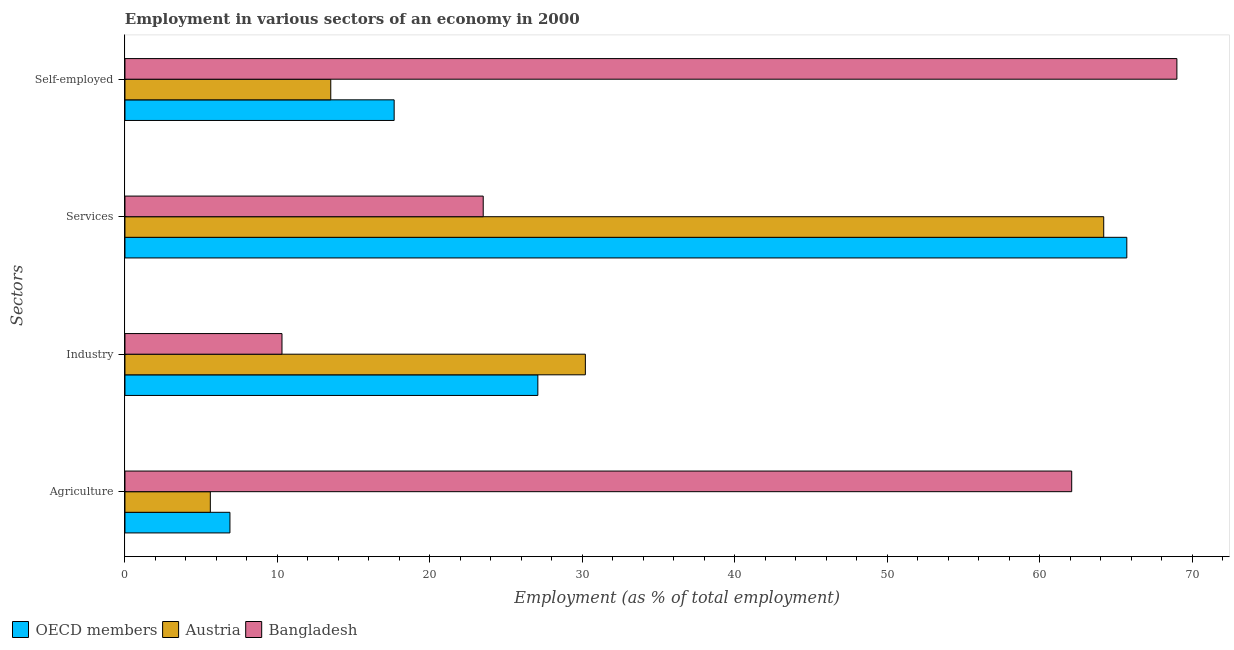How many groups of bars are there?
Offer a very short reply. 4. Are the number of bars per tick equal to the number of legend labels?
Provide a succinct answer. Yes. Are the number of bars on each tick of the Y-axis equal?
Provide a succinct answer. Yes. How many bars are there on the 1st tick from the bottom?
Offer a terse response. 3. What is the label of the 2nd group of bars from the top?
Keep it short and to the point. Services. What is the percentage of workers in industry in Austria?
Your response must be concise. 30.2. Across all countries, what is the maximum percentage of workers in agriculture?
Ensure brevity in your answer.  62.1. In which country was the percentage of self employed workers maximum?
Your answer should be very brief. Bangladesh. In which country was the percentage of workers in services minimum?
Keep it short and to the point. Bangladesh. What is the total percentage of workers in agriculture in the graph?
Make the answer very short. 74.59. What is the difference between the percentage of workers in industry in OECD members and that in Austria?
Keep it short and to the point. -3.12. What is the difference between the percentage of self employed workers in OECD members and the percentage of workers in services in Bangladesh?
Your response must be concise. -5.84. What is the average percentage of workers in agriculture per country?
Provide a succinct answer. 24.86. What is the difference between the percentage of workers in agriculture and percentage of self employed workers in Bangladesh?
Your answer should be compact. -6.9. What is the ratio of the percentage of workers in services in Bangladesh to that in OECD members?
Make the answer very short. 0.36. Is the percentage of self employed workers in Bangladesh less than that in Austria?
Give a very brief answer. No. What is the difference between the highest and the second highest percentage of workers in services?
Ensure brevity in your answer.  1.52. What is the difference between the highest and the lowest percentage of workers in services?
Your answer should be compact. 42.22. In how many countries, is the percentage of workers in agriculture greater than the average percentage of workers in agriculture taken over all countries?
Your answer should be compact. 1. Is it the case that in every country, the sum of the percentage of workers in services and percentage of self employed workers is greater than the sum of percentage of workers in agriculture and percentage of workers in industry?
Provide a succinct answer. No. Is it the case that in every country, the sum of the percentage of workers in agriculture and percentage of workers in industry is greater than the percentage of workers in services?
Provide a short and direct response. No. Are all the bars in the graph horizontal?
Offer a very short reply. Yes. How many countries are there in the graph?
Ensure brevity in your answer.  3. Does the graph contain any zero values?
Your answer should be compact. No. How are the legend labels stacked?
Offer a terse response. Horizontal. What is the title of the graph?
Keep it short and to the point. Employment in various sectors of an economy in 2000. Does "East Asia (all income levels)" appear as one of the legend labels in the graph?
Your answer should be very brief. No. What is the label or title of the X-axis?
Keep it short and to the point. Employment (as % of total employment). What is the label or title of the Y-axis?
Offer a terse response. Sectors. What is the Employment (as % of total employment) of OECD members in Agriculture?
Give a very brief answer. 6.89. What is the Employment (as % of total employment) of Austria in Agriculture?
Keep it short and to the point. 5.6. What is the Employment (as % of total employment) of Bangladesh in Agriculture?
Give a very brief answer. 62.1. What is the Employment (as % of total employment) of OECD members in Industry?
Give a very brief answer. 27.08. What is the Employment (as % of total employment) of Austria in Industry?
Keep it short and to the point. 30.2. What is the Employment (as % of total employment) of Bangladesh in Industry?
Ensure brevity in your answer.  10.3. What is the Employment (as % of total employment) of OECD members in Services?
Keep it short and to the point. 65.72. What is the Employment (as % of total employment) in Austria in Services?
Your answer should be compact. 64.2. What is the Employment (as % of total employment) in OECD members in Self-employed?
Give a very brief answer. 17.66. What is the Employment (as % of total employment) of Austria in Self-employed?
Make the answer very short. 13.5. Across all Sectors, what is the maximum Employment (as % of total employment) in OECD members?
Give a very brief answer. 65.72. Across all Sectors, what is the maximum Employment (as % of total employment) of Austria?
Provide a succinct answer. 64.2. Across all Sectors, what is the minimum Employment (as % of total employment) of OECD members?
Give a very brief answer. 6.89. Across all Sectors, what is the minimum Employment (as % of total employment) of Austria?
Offer a very short reply. 5.6. Across all Sectors, what is the minimum Employment (as % of total employment) in Bangladesh?
Offer a terse response. 10.3. What is the total Employment (as % of total employment) of OECD members in the graph?
Your response must be concise. 117.34. What is the total Employment (as % of total employment) in Austria in the graph?
Give a very brief answer. 113.5. What is the total Employment (as % of total employment) in Bangladesh in the graph?
Make the answer very short. 164.9. What is the difference between the Employment (as % of total employment) of OECD members in Agriculture and that in Industry?
Offer a very short reply. -20.2. What is the difference between the Employment (as % of total employment) of Austria in Agriculture and that in Industry?
Provide a short and direct response. -24.6. What is the difference between the Employment (as % of total employment) in Bangladesh in Agriculture and that in Industry?
Offer a very short reply. 51.8. What is the difference between the Employment (as % of total employment) in OECD members in Agriculture and that in Services?
Offer a terse response. -58.83. What is the difference between the Employment (as % of total employment) in Austria in Agriculture and that in Services?
Your answer should be compact. -58.6. What is the difference between the Employment (as % of total employment) in Bangladesh in Agriculture and that in Services?
Provide a short and direct response. 38.6. What is the difference between the Employment (as % of total employment) in OECD members in Agriculture and that in Self-employed?
Ensure brevity in your answer.  -10.77. What is the difference between the Employment (as % of total employment) of Austria in Agriculture and that in Self-employed?
Make the answer very short. -7.9. What is the difference between the Employment (as % of total employment) of Bangladesh in Agriculture and that in Self-employed?
Your answer should be compact. -6.9. What is the difference between the Employment (as % of total employment) in OECD members in Industry and that in Services?
Keep it short and to the point. -38.63. What is the difference between the Employment (as % of total employment) of Austria in Industry and that in Services?
Provide a short and direct response. -34. What is the difference between the Employment (as % of total employment) of Bangladesh in Industry and that in Services?
Give a very brief answer. -13.2. What is the difference between the Employment (as % of total employment) in OECD members in Industry and that in Self-employed?
Offer a terse response. 9.43. What is the difference between the Employment (as % of total employment) in Austria in Industry and that in Self-employed?
Ensure brevity in your answer.  16.7. What is the difference between the Employment (as % of total employment) of Bangladesh in Industry and that in Self-employed?
Make the answer very short. -58.7. What is the difference between the Employment (as % of total employment) in OECD members in Services and that in Self-employed?
Ensure brevity in your answer.  48.06. What is the difference between the Employment (as % of total employment) in Austria in Services and that in Self-employed?
Offer a terse response. 50.7. What is the difference between the Employment (as % of total employment) in Bangladesh in Services and that in Self-employed?
Your response must be concise. -45.5. What is the difference between the Employment (as % of total employment) of OECD members in Agriculture and the Employment (as % of total employment) of Austria in Industry?
Provide a succinct answer. -23.31. What is the difference between the Employment (as % of total employment) of OECD members in Agriculture and the Employment (as % of total employment) of Bangladesh in Industry?
Ensure brevity in your answer.  -3.41. What is the difference between the Employment (as % of total employment) of OECD members in Agriculture and the Employment (as % of total employment) of Austria in Services?
Provide a succinct answer. -57.31. What is the difference between the Employment (as % of total employment) of OECD members in Agriculture and the Employment (as % of total employment) of Bangladesh in Services?
Give a very brief answer. -16.61. What is the difference between the Employment (as % of total employment) of Austria in Agriculture and the Employment (as % of total employment) of Bangladesh in Services?
Keep it short and to the point. -17.9. What is the difference between the Employment (as % of total employment) in OECD members in Agriculture and the Employment (as % of total employment) in Austria in Self-employed?
Provide a succinct answer. -6.61. What is the difference between the Employment (as % of total employment) in OECD members in Agriculture and the Employment (as % of total employment) in Bangladesh in Self-employed?
Ensure brevity in your answer.  -62.11. What is the difference between the Employment (as % of total employment) of Austria in Agriculture and the Employment (as % of total employment) of Bangladesh in Self-employed?
Ensure brevity in your answer.  -63.4. What is the difference between the Employment (as % of total employment) in OECD members in Industry and the Employment (as % of total employment) in Austria in Services?
Ensure brevity in your answer.  -37.12. What is the difference between the Employment (as % of total employment) of OECD members in Industry and the Employment (as % of total employment) of Bangladesh in Services?
Make the answer very short. 3.58. What is the difference between the Employment (as % of total employment) of OECD members in Industry and the Employment (as % of total employment) of Austria in Self-employed?
Make the answer very short. 13.58. What is the difference between the Employment (as % of total employment) in OECD members in Industry and the Employment (as % of total employment) in Bangladesh in Self-employed?
Provide a short and direct response. -41.92. What is the difference between the Employment (as % of total employment) in Austria in Industry and the Employment (as % of total employment) in Bangladesh in Self-employed?
Make the answer very short. -38.8. What is the difference between the Employment (as % of total employment) in OECD members in Services and the Employment (as % of total employment) in Austria in Self-employed?
Your response must be concise. 52.22. What is the difference between the Employment (as % of total employment) in OECD members in Services and the Employment (as % of total employment) in Bangladesh in Self-employed?
Your answer should be very brief. -3.28. What is the difference between the Employment (as % of total employment) of Austria in Services and the Employment (as % of total employment) of Bangladesh in Self-employed?
Offer a terse response. -4.8. What is the average Employment (as % of total employment) in OECD members per Sectors?
Make the answer very short. 29.34. What is the average Employment (as % of total employment) in Austria per Sectors?
Your answer should be very brief. 28.38. What is the average Employment (as % of total employment) of Bangladesh per Sectors?
Your response must be concise. 41.23. What is the difference between the Employment (as % of total employment) in OECD members and Employment (as % of total employment) in Austria in Agriculture?
Ensure brevity in your answer.  1.29. What is the difference between the Employment (as % of total employment) in OECD members and Employment (as % of total employment) in Bangladesh in Agriculture?
Your answer should be compact. -55.21. What is the difference between the Employment (as % of total employment) of Austria and Employment (as % of total employment) of Bangladesh in Agriculture?
Provide a succinct answer. -56.5. What is the difference between the Employment (as % of total employment) in OECD members and Employment (as % of total employment) in Austria in Industry?
Make the answer very short. -3.12. What is the difference between the Employment (as % of total employment) of OECD members and Employment (as % of total employment) of Bangladesh in Industry?
Keep it short and to the point. 16.78. What is the difference between the Employment (as % of total employment) of Austria and Employment (as % of total employment) of Bangladesh in Industry?
Ensure brevity in your answer.  19.9. What is the difference between the Employment (as % of total employment) in OECD members and Employment (as % of total employment) in Austria in Services?
Provide a succinct answer. 1.52. What is the difference between the Employment (as % of total employment) in OECD members and Employment (as % of total employment) in Bangladesh in Services?
Keep it short and to the point. 42.22. What is the difference between the Employment (as % of total employment) of Austria and Employment (as % of total employment) of Bangladesh in Services?
Keep it short and to the point. 40.7. What is the difference between the Employment (as % of total employment) in OECD members and Employment (as % of total employment) in Austria in Self-employed?
Give a very brief answer. 4.16. What is the difference between the Employment (as % of total employment) in OECD members and Employment (as % of total employment) in Bangladesh in Self-employed?
Make the answer very short. -51.34. What is the difference between the Employment (as % of total employment) in Austria and Employment (as % of total employment) in Bangladesh in Self-employed?
Offer a very short reply. -55.5. What is the ratio of the Employment (as % of total employment) in OECD members in Agriculture to that in Industry?
Offer a terse response. 0.25. What is the ratio of the Employment (as % of total employment) of Austria in Agriculture to that in Industry?
Your response must be concise. 0.19. What is the ratio of the Employment (as % of total employment) in Bangladesh in Agriculture to that in Industry?
Your answer should be very brief. 6.03. What is the ratio of the Employment (as % of total employment) of OECD members in Agriculture to that in Services?
Your answer should be very brief. 0.1. What is the ratio of the Employment (as % of total employment) of Austria in Agriculture to that in Services?
Your answer should be very brief. 0.09. What is the ratio of the Employment (as % of total employment) of Bangladesh in Agriculture to that in Services?
Offer a very short reply. 2.64. What is the ratio of the Employment (as % of total employment) of OECD members in Agriculture to that in Self-employed?
Your answer should be compact. 0.39. What is the ratio of the Employment (as % of total employment) in Austria in Agriculture to that in Self-employed?
Give a very brief answer. 0.41. What is the ratio of the Employment (as % of total employment) of OECD members in Industry to that in Services?
Give a very brief answer. 0.41. What is the ratio of the Employment (as % of total employment) in Austria in Industry to that in Services?
Provide a succinct answer. 0.47. What is the ratio of the Employment (as % of total employment) of Bangladesh in Industry to that in Services?
Make the answer very short. 0.44. What is the ratio of the Employment (as % of total employment) in OECD members in Industry to that in Self-employed?
Ensure brevity in your answer.  1.53. What is the ratio of the Employment (as % of total employment) in Austria in Industry to that in Self-employed?
Your answer should be compact. 2.24. What is the ratio of the Employment (as % of total employment) in Bangladesh in Industry to that in Self-employed?
Your response must be concise. 0.15. What is the ratio of the Employment (as % of total employment) of OECD members in Services to that in Self-employed?
Your response must be concise. 3.72. What is the ratio of the Employment (as % of total employment) of Austria in Services to that in Self-employed?
Provide a succinct answer. 4.76. What is the ratio of the Employment (as % of total employment) in Bangladesh in Services to that in Self-employed?
Offer a terse response. 0.34. What is the difference between the highest and the second highest Employment (as % of total employment) of OECD members?
Offer a very short reply. 38.63. What is the difference between the highest and the lowest Employment (as % of total employment) in OECD members?
Make the answer very short. 58.83. What is the difference between the highest and the lowest Employment (as % of total employment) of Austria?
Make the answer very short. 58.6. What is the difference between the highest and the lowest Employment (as % of total employment) of Bangladesh?
Ensure brevity in your answer.  58.7. 